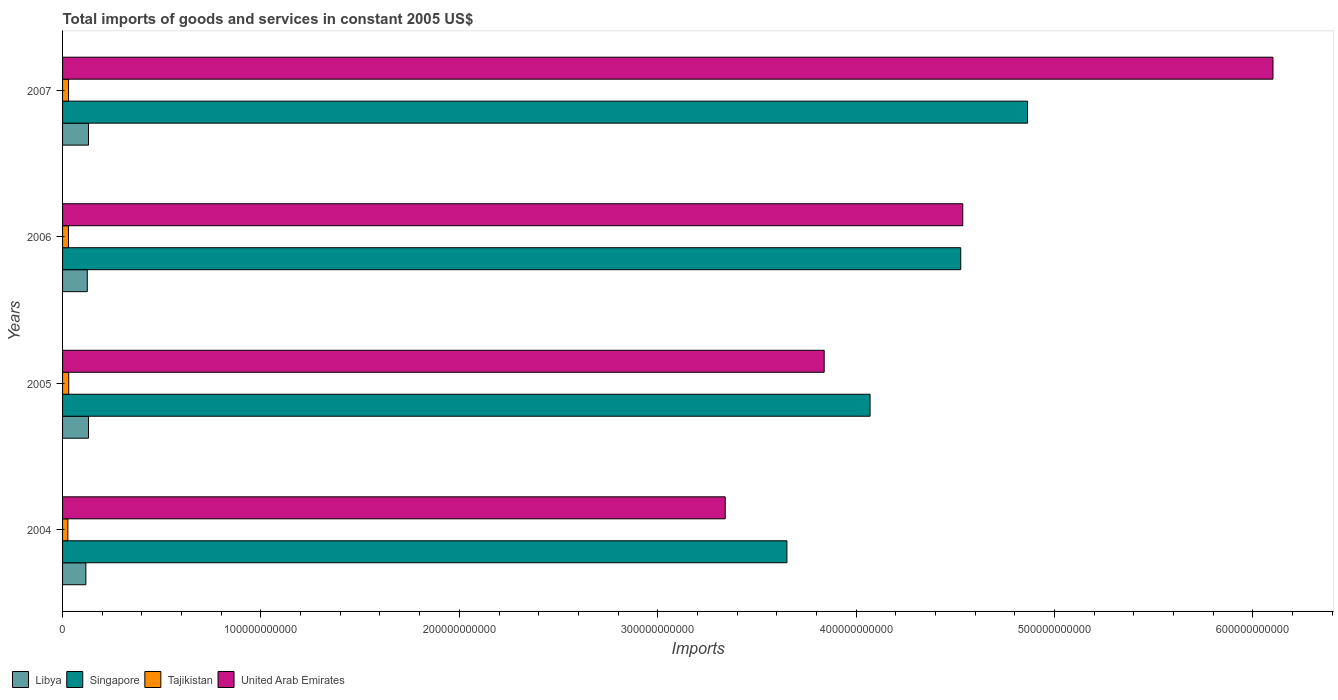How many different coloured bars are there?
Your answer should be compact. 4. Are the number of bars per tick equal to the number of legend labels?
Make the answer very short. Yes. How many bars are there on the 3rd tick from the top?
Make the answer very short. 4. What is the label of the 3rd group of bars from the top?
Offer a terse response. 2005. What is the total imports of goods and services in Libya in 2004?
Ensure brevity in your answer.  1.17e+1. Across all years, what is the maximum total imports of goods and services in Tajikistan?
Make the answer very short. 3.11e+09. Across all years, what is the minimum total imports of goods and services in Libya?
Your answer should be very brief. 1.17e+1. In which year was the total imports of goods and services in United Arab Emirates maximum?
Keep it short and to the point. 2007. What is the total total imports of goods and services in Libya in the graph?
Keep it short and to the point. 5.04e+1. What is the difference between the total imports of goods and services in Libya in 2005 and that in 2006?
Your response must be concise. 6.27e+08. What is the difference between the total imports of goods and services in Libya in 2004 and the total imports of goods and services in Singapore in 2005?
Keep it short and to the point. -3.95e+11. What is the average total imports of goods and services in Tajikistan per year?
Your answer should be compact. 2.94e+09. In the year 2005, what is the difference between the total imports of goods and services in Singapore and total imports of goods and services in Tajikistan?
Keep it short and to the point. 4.04e+11. What is the ratio of the total imports of goods and services in Libya in 2004 to that in 2005?
Provide a short and direct response. 0.9. What is the difference between the highest and the second highest total imports of goods and services in Tajikistan?
Offer a very short reply. 8.21e+07. What is the difference between the highest and the lowest total imports of goods and services in Singapore?
Give a very brief answer. 1.21e+11. In how many years, is the total imports of goods and services in United Arab Emirates greater than the average total imports of goods and services in United Arab Emirates taken over all years?
Provide a succinct answer. 2. Is it the case that in every year, the sum of the total imports of goods and services in Singapore and total imports of goods and services in Libya is greater than the sum of total imports of goods and services in Tajikistan and total imports of goods and services in United Arab Emirates?
Your answer should be compact. Yes. What does the 1st bar from the top in 2007 represents?
Offer a very short reply. United Arab Emirates. What does the 3rd bar from the bottom in 2005 represents?
Your answer should be compact. Tajikistan. How many bars are there?
Offer a very short reply. 16. How many years are there in the graph?
Your answer should be very brief. 4. What is the difference between two consecutive major ticks on the X-axis?
Keep it short and to the point. 1.00e+11. Are the values on the major ticks of X-axis written in scientific E-notation?
Make the answer very short. No. Does the graph contain any zero values?
Provide a succinct answer. No. Does the graph contain grids?
Offer a terse response. No. Where does the legend appear in the graph?
Offer a very short reply. Bottom left. How many legend labels are there?
Make the answer very short. 4. How are the legend labels stacked?
Give a very brief answer. Horizontal. What is the title of the graph?
Your answer should be very brief. Total imports of goods and services in constant 2005 US$. Does "Costa Rica" appear as one of the legend labels in the graph?
Make the answer very short. No. What is the label or title of the X-axis?
Give a very brief answer. Imports. What is the Imports in Libya in 2004?
Offer a very short reply. 1.17e+1. What is the Imports of Singapore in 2004?
Your answer should be compact. 3.65e+11. What is the Imports in Tajikistan in 2004?
Your answer should be very brief. 2.67e+09. What is the Imports of United Arab Emirates in 2004?
Provide a succinct answer. 3.34e+11. What is the Imports of Libya in 2005?
Provide a short and direct response. 1.31e+1. What is the Imports of Singapore in 2005?
Give a very brief answer. 4.07e+11. What is the Imports of Tajikistan in 2005?
Your answer should be compact. 3.11e+09. What is the Imports in United Arab Emirates in 2005?
Make the answer very short. 3.84e+11. What is the Imports in Libya in 2006?
Your response must be concise. 1.25e+1. What is the Imports of Singapore in 2006?
Your response must be concise. 4.53e+11. What is the Imports of Tajikistan in 2006?
Your response must be concise. 2.97e+09. What is the Imports of United Arab Emirates in 2006?
Give a very brief answer. 4.54e+11. What is the Imports of Libya in 2007?
Provide a short and direct response. 1.31e+1. What is the Imports of Singapore in 2007?
Your answer should be very brief. 4.86e+11. What is the Imports of Tajikistan in 2007?
Keep it short and to the point. 3.03e+09. What is the Imports of United Arab Emirates in 2007?
Provide a short and direct response. 6.10e+11. Across all years, what is the maximum Imports in Libya?
Your answer should be compact. 1.31e+1. Across all years, what is the maximum Imports of Singapore?
Your response must be concise. 4.86e+11. Across all years, what is the maximum Imports in Tajikistan?
Make the answer very short. 3.11e+09. Across all years, what is the maximum Imports of United Arab Emirates?
Ensure brevity in your answer.  6.10e+11. Across all years, what is the minimum Imports of Libya?
Your response must be concise. 1.17e+1. Across all years, what is the minimum Imports of Singapore?
Make the answer very short. 3.65e+11. Across all years, what is the minimum Imports of Tajikistan?
Your answer should be compact. 2.67e+09. Across all years, what is the minimum Imports of United Arab Emirates?
Make the answer very short. 3.34e+11. What is the total Imports in Libya in the graph?
Provide a short and direct response. 5.04e+1. What is the total Imports of Singapore in the graph?
Give a very brief answer. 1.71e+12. What is the total Imports in Tajikistan in the graph?
Give a very brief answer. 1.18e+1. What is the total Imports in United Arab Emirates in the graph?
Your response must be concise. 1.78e+12. What is the difference between the Imports of Libya in 2004 and that in 2005?
Ensure brevity in your answer.  -1.34e+09. What is the difference between the Imports of Singapore in 2004 and that in 2005?
Your response must be concise. -4.19e+1. What is the difference between the Imports of Tajikistan in 2004 and that in 2005?
Offer a very short reply. -4.40e+08. What is the difference between the Imports of United Arab Emirates in 2004 and that in 2005?
Your response must be concise. -4.99e+1. What is the difference between the Imports of Libya in 2004 and that in 2006?
Your answer should be compact. -7.14e+08. What is the difference between the Imports in Singapore in 2004 and that in 2006?
Offer a very short reply. -8.76e+1. What is the difference between the Imports in Tajikistan in 2004 and that in 2006?
Ensure brevity in your answer.  -3.07e+08. What is the difference between the Imports in United Arab Emirates in 2004 and that in 2006?
Your answer should be compact. -1.20e+11. What is the difference between the Imports in Libya in 2004 and that in 2007?
Your response must be concise. -1.34e+09. What is the difference between the Imports in Singapore in 2004 and that in 2007?
Your answer should be very brief. -1.21e+11. What is the difference between the Imports in Tajikistan in 2004 and that in 2007?
Provide a short and direct response. -3.58e+08. What is the difference between the Imports in United Arab Emirates in 2004 and that in 2007?
Make the answer very short. -2.76e+11. What is the difference between the Imports in Libya in 2005 and that in 2006?
Provide a succinct answer. 6.27e+08. What is the difference between the Imports of Singapore in 2005 and that in 2006?
Keep it short and to the point. -4.57e+1. What is the difference between the Imports in Tajikistan in 2005 and that in 2006?
Provide a succinct answer. 1.33e+08. What is the difference between the Imports in United Arab Emirates in 2005 and that in 2006?
Provide a short and direct response. -6.99e+1. What is the difference between the Imports of Libya in 2005 and that in 2007?
Ensure brevity in your answer.  -3.46e+06. What is the difference between the Imports of Singapore in 2005 and that in 2007?
Your answer should be compact. -7.94e+1. What is the difference between the Imports of Tajikistan in 2005 and that in 2007?
Make the answer very short. 8.21e+07. What is the difference between the Imports in United Arab Emirates in 2005 and that in 2007?
Offer a very short reply. -2.26e+11. What is the difference between the Imports of Libya in 2006 and that in 2007?
Ensure brevity in your answer.  -6.30e+08. What is the difference between the Imports of Singapore in 2006 and that in 2007?
Offer a terse response. -3.37e+1. What is the difference between the Imports of Tajikistan in 2006 and that in 2007?
Your answer should be very brief. -5.14e+07. What is the difference between the Imports of United Arab Emirates in 2006 and that in 2007?
Keep it short and to the point. -1.56e+11. What is the difference between the Imports in Libya in 2004 and the Imports in Singapore in 2005?
Offer a very short reply. -3.95e+11. What is the difference between the Imports of Libya in 2004 and the Imports of Tajikistan in 2005?
Your response must be concise. 8.63e+09. What is the difference between the Imports of Libya in 2004 and the Imports of United Arab Emirates in 2005?
Your answer should be very brief. -3.72e+11. What is the difference between the Imports of Singapore in 2004 and the Imports of Tajikistan in 2005?
Ensure brevity in your answer.  3.62e+11. What is the difference between the Imports in Singapore in 2004 and the Imports in United Arab Emirates in 2005?
Offer a terse response. -1.88e+1. What is the difference between the Imports in Tajikistan in 2004 and the Imports in United Arab Emirates in 2005?
Keep it short and to the point. -3.81e+11. What is the difference between the Imports in Libya in 2004 and the Imports in Singapore in 2006?
Ensure brevity in your answer.  -4.41e+11. What is the difference between the Imports of Libya in 2004 and the Imports of Tajikistan in 2006?
Give a very brief answer. 8.77e+09. What is the difference between the Imports in Libya in 2004 and the Imports in United Arab Emirates in 2006?
Offer a very short reply. -4.42e+11. What is the difference between the Imports of Singapore in 2004 and the Imports of Tajikistan in 2006?
Ensure brevity in your answer.  3.62e+11. What is the difference between the Imports of Singapore in 2004 and the Imports of United Arab Emirates in 2006?
Offer a very short reply. -8.86e+1. What is the difference between the Imports of Tajikistan in 2004 and the Imports of United Arab Emirates in 2006?
Keep it short and to the point. -4.51e+11. What is the difference between the Imports of Libya in 2004 and the Imports of Singapore in 2007?
Your answer should be compact. -4.75e+11. What is the difference between the Imports in Libya in 2004 and the Imports in Tajikistan in 2007?
Provide a short and direct response. 8.71e+09. What is the difference between the Imports in Libya in 2004 and the Imports in United Arab Emirates in 2007?
Your response must be concise. -5.98e+11. What is the difference between the Imports of Singapore in 2004 and the Imports of Tajikistan in 2007?
Your answer should be compact. 3.62e+11. What is the difference between the Imports of Singapore in 2004 and the Imports of United Arab Emirates in 2007?
Provide a short and direct response. -2.45e+11. What is the difference between the Imports of Tajikistan in 2004 and the Imports of United Arab Emirates in 2007?
Offer a very short reply. -6.07e+11. What is the difference between the Imports in Libya in 2005 and the Imports in Singapore in 2006?
Offer a terse response. -4.40e+11. What is the difference between the Imports in Libya in 2005 and the Imports in Tajikistan in 2006?
Your response must be concise. 1.01e+1. What is the difference between the Imports of Libya in 2005 and the Imports of United Arab Emirates in 2006?
Your response must be concise. -4.41e+11. What is the difference between the Imports of Singapore in 2005 and the Imports of Tajikistan in 2006?
Your response must be concise. 4.04e+11. What is the difference between the Imports of Singapore in 2005 and the Imports of United Arab Emirates in 2006?
Offer a very short reply. -4.67e+1. What is the difference between the Imports of Tajikistan in 2005 and the Imports of United Arab Emirates in 2006?
Your response must be concise. -4.51e+11. What is the difference between the Imports in Libya in 2005 and the Imports in Singapore in 2007?
Your response must be concise. -4.73e+11. What is the difference between the Imports of Libya in 2005 and the Imports of Tajikistan in 2007?
Ensure brevity in your answer.  1.01e+1. What is the difference between the Imports of Libya in 2005 and the Imports of United Arab Emirates in 2007?
Provide a succinct answer. -5.97e+11. What is the difference between the Imports of Singapore in 2005 and the Imports of Tajikistan in 2007?
Provide a succinct answer. 4.04e+11. What is the difference between the Imports in Singapore in 2005 and the Imports in United Arab Emirates in 2007?
Keep it short and to the point. -2.03e+11. What is the difference between the Imports of Tajikistan in 2005 and the Imports of United Arab Emirates in 2007?
Your response must be concise. -6.07e+11. What is the difference between the Imports in Libya in 2006 and the Imports in Singapore in 2007?
Provide a succinct answer. -4.74e+11. What is the difference between the Imports in Libya in 2006 and the Imports in Tajikistan in 2007?
Provide a short and direct response. 9.43e+09. What is the difference between the Imports of Libya in 2006 and the Imports of United Arab Emirates in 2007?
Offer a very short reply. -5.98e+11. What is the difference between the Imports of Singapore in 2006 and the Imports of Tajikistan in 2007?
Make the answer very short. 4.50e+11. What is the difference between the Imports in Singapore in 2006 and the Imports in United Arab Emirates in 2007?
Make the answer very short. -1.57e+11. What is the difference between the Imports in Tajikistan in 2006 and the Imports in United Arab Emirates in 2007?
Keep it short and to the point. -6.07e+11. What is the average Imports in Libya per year?
Your answer should be very brief. 1.26e+1. What is the average Imports in Singapore per year?
Ensure brevity in your answer.  4.28e+11. What is the average Imports of Tajikistan per year?
Your response must be concise. 2.94e+09. What is the average Imports in United Arab Emirates per year?
Your answer should be compact. 4.45e+11. In the year 2004, what is the difference between the Imports of Libya and Imports of Singapore?
Your answer should be compact. -3.53e+11. In the year 2004, what is the difference between the Imports of Libya and Imports of Tajikistan?
Your answer should be compact. 9.07e+09. In the year 2004, what is the difference between the Imports in Libya and Imports in United Arab Emirates?
Keep it short and to the point. -3.22e+11. In the year 2004, what is the difference between the Imports in Singapore and Imports in Tajikistan?
Provide a succinct answer. 3.62e+11. In the year 2004, what is the difference between the Imports in Singapore and Imports in United Arab Emirates?
Your response must be concise. 3.11e+1. In the year 2004, what is the difference between the Imports in Tajikistan and Imports in United Arab Emirates?
Keep it short and to the point. -3.31e+11. In the year 2005, what is the difference between the Imports of Libya and Imports of Singapore?
Your response must be concise. -3.94e+11. In the year 2005, what is the difference between the Imports of Libya and Imports of Tajikistan?
Give a very brief answer. 9.97e+09. In the year 2005, what is the difference between the Imports of Libya and Imports of United Arab Emirates?
Keep it short and to the point. -3.71e+11. In the year 2005, what is the difference between the Imports in Singapore and Imports in Tajikistan?
Provide a short and direct response. 4.04e+11. In the year 2005, what is the difference between the Imports in Singapore and Imports in United Arab Emirates?
Your answer should be compact. 2.31e+1. In the year 2005, what is the difference between the Imports in Tajikistan and Imports in United Arab Emirates?
Offer a terse response. -3.81e+11. In the year 2006, what is the difference between the Imports of Libya and Imports of Singapore?
Offer a terse response. -4.40e+11. In the year 2006, what is the difference between the Imports in Libya and Imports in Tajikistan?
Provide a succinct answer. 9.48e+09. In the year 2006, what is the difference between the Imports of Libya and Imports of United Arab Emirates?
Your answer should be compact. -4.41e+11. In the year 2006, what is the difference between the Imports in Singapore and Imports in Tajikistan?
Give a very brief answer. 4.50e+11. In the year 2006, what is the difference between the Imports of Singapore and Imports of United Arab Emirates?
Ensure brevity in your answer.  -1.02e+09. In the year 2006, what is the difference between the Imports of Tajikistan and Imports of United Arab Emirates?
Keep it short and to the point. -4.51e+11. In the year 2007, what is the difference between the Imports of Libya and Imports of Singapore?
Your answer should be compact. -4.73e+11. In the year 2007, what is the difference between the Imports of Libya and Imports of Tajikistan?
Your answer should be compact. 1.01e+1. In the year 2007, what is the difference between the Imports of Libya and Imports of United Arab Emirates?
Your answer should be very brief. -5.97e+11. In the year 2007, what is the difference between the Imports of Singapore and Imports of Tajikistan?
Your answer should be compact. 4.83e+11. In the year 2007, what is the difference between the Imports in Singapore and Imports in United Arab Emirates?
Your answer should be compact. -1.24e+11. In the year 2007, what is the difference between the Imports of Tajikistan and Imports of United Arab Emirates?
Provide a succinct answer. -6.07e+11. What is the ratio of the Imports of Libya in 2004 to that in 2005?
Your answer should be compact. 0.9. What is the ratio of the Imports of Singapore in 2004 to that in 2005?
Provide a succinct answer. 0.9. What is the ratio of the Imports of Tajikistan in 2004 to that in 2005?
Provide a short and direct response. 0.86. What is the ratio of the Imports in United Arab Emirates in 2004 to that in 2005?
Keep it short and to the point. 0.87. What is the ratio of the Imports of Libya in 2004 to that in 2006?
Provide a succinct answer. 0.94. What is the ratio of the Imports of Singapore in 2004 to that in 2006?
Your answer should be compact. 0.81. What is the ratio of the Imports of Tajikistan in 2004 to that in 2006?
Your answer should be very brief. 0.9. What is the ratio of the Imports in United Arab Emirates in 2004 to that in 2006?
Offer a terse response. 0.74. What is the ratio of the Imports of Libya in 2004 to that in 2007?
Make the answer very short. 0.9. What is the ratio of the Imports of Singapore in 2004 to that in 2007?
Your answer should be compact. 0.75. What is the ratio of the Imports in Tajikistan in 2004 to that in 2007?
Provide a succinct answer. 0.88. What is the ratio of the Imports in United Arab Emirates in 2004 to that in 2007?
Offer a terse response. 0.55. What is the ratio of the Imports in Libya in 2005 to that in 2006?
Your response must be concise. 1.05. What is the ratio of the Imports of Singapore in 2005 to that in 2006?
Offer a terse response. 0.9. What is the ratio of the Imports of Tajikistan in 2005 to that in 2006?
Offer a terse response. 1.04. What is the ratio of the Imports of United Arab Emirates in 2005 to that in 2006?
Offer a very short reply. 0.85. What is the ratio of the Imports in Singapore in 2005 to that in 2007?
Give a very brief answer. 0.84. What is the ratio of the Imports of Tajikistan in 2005 to that in 2007?
Give a very brief answer. 1.03. What is the ratio of the Imports in United Arab Emirates in 2005 to that in 2007?
Offer a very short reply. 0.63. What is the ratio of the Imports in Libya in 2006 to that in 2007?
Give a very brief answer. 0.95. What is the ratio of the Imports in Singapore in 2006 to that in 2007?
Offer a very short reply. 0.93. What is the ratio of the Imports of United Arab Emirates in 2006 to that in 2007?
Offer a terse response. 0.74. What is the difference between the highest and the second highest Imports of Libya?
Make the answer very short. 3.46e+06. What is the difference between the highest and the second highest Imports of Singapore?
Your response must be concise. 3.37e+1. What is the difference between the highest and the second highest Imports of Tajikistan?
Offer a terse response. 8.21e+07. What is the difference between the highest and the second highest Imports of United Arab Emirates?
Give a very brief answer. 1.56e+11. What is the difference between the highest and the lowest Imports of Libya?
Give a very brief answer. 1.34e+09. What is the difference between the highest and the lowest Imports in Singapore?
Provide a succinct answer. 1.21e+11. What is the difference between the highest and the lowest Imports in Tajikistan?
Provide a succinct answer. 4.40e+08. What is the difference between the highest and the lowest Imports in United Arab Emirates?
Ensure brevity in your answer.  2.76e+11. 